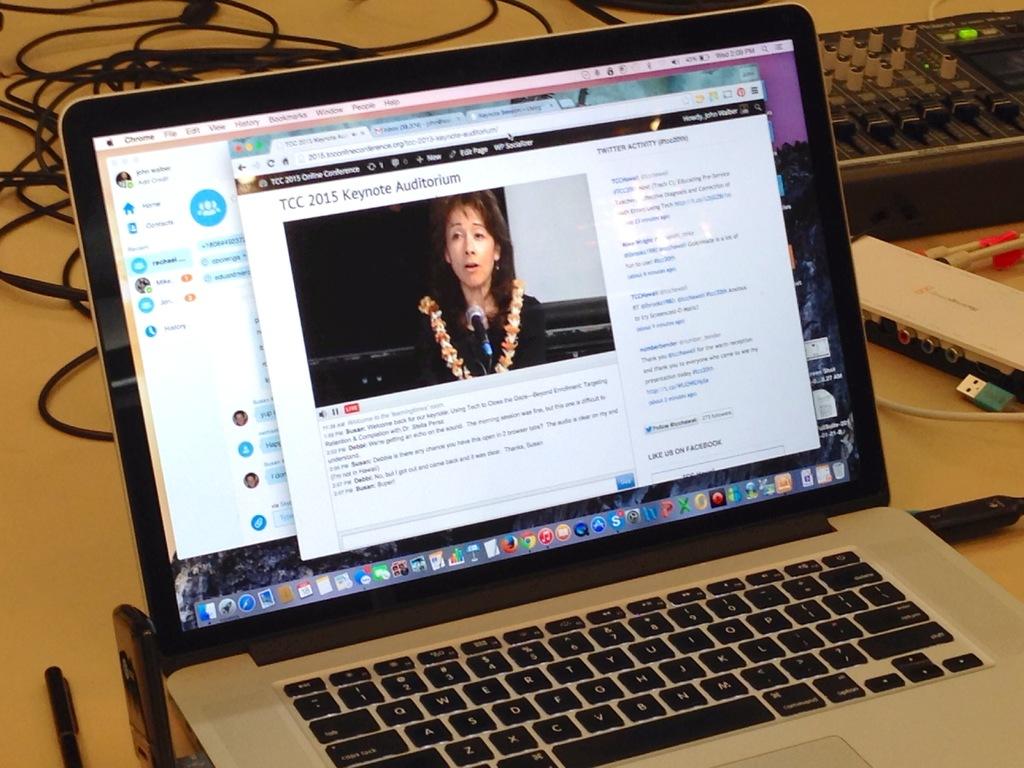Who makes this laptop?
Offer a terse response. Unanswerable. Which browser currently open in this laptop?
Keep it short and to the point. Chrome. 